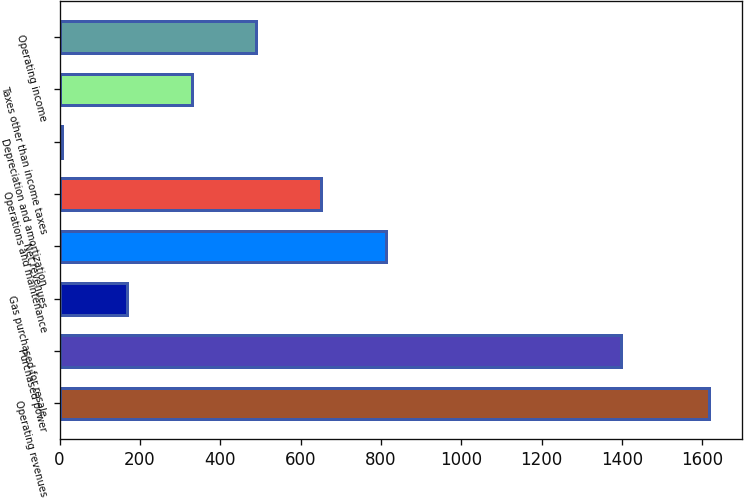Convert chart. <chart><loc_0><loc_0><loc_500><loc_500><bar_chart><fcel>Operating revenues<fcel>Purchased power<fcel>Gas purchased for resale<fcel>Net revenues<fcel>Operations and maintenance<fcel>Depreciation and amortization<fcel>Taxes other than income taxes<fcel>Operating income<nl><fcel>1617<fcel>1397<fcel>168<fcel>812<fcel>651<fcel>7<fcel>329<fcel>490<nl></chart> 